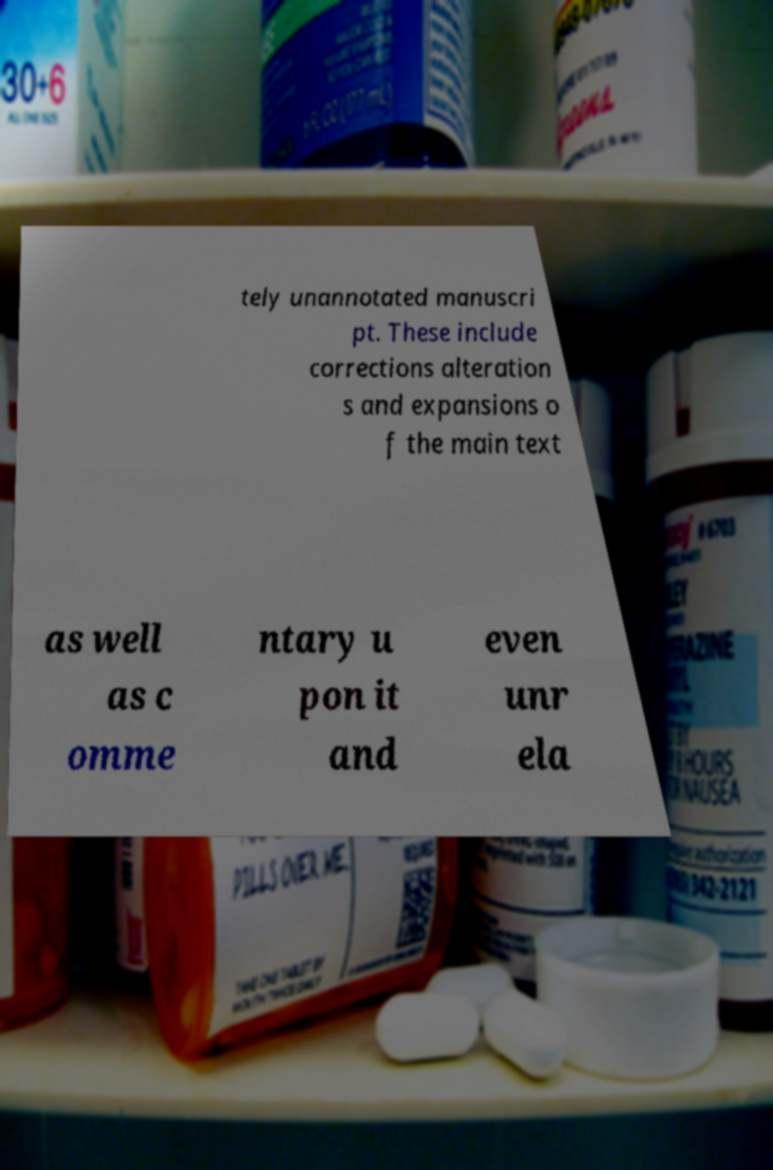I need the written content from this picture converted into text. Can you do that? tely unannotated manuscri pt. These include corrections alteration s and expansions o f the main text as well as c omme ntary u pon it and even unr ela 